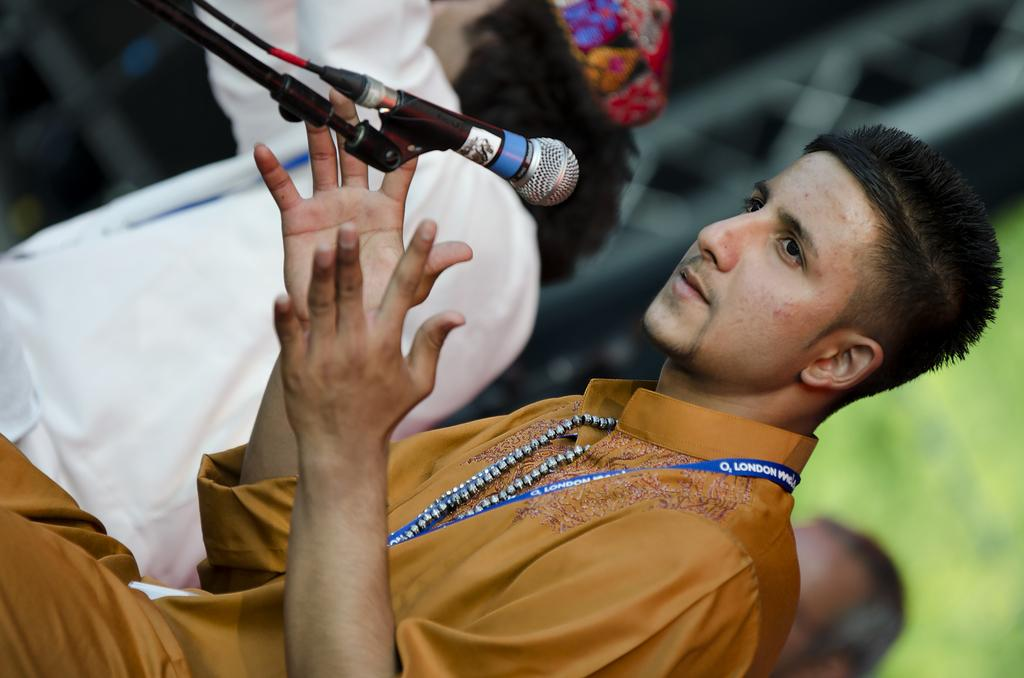What is the boy in the image doing? The boy is sitting in the image. What object is present in the image that is typically used for amplifying sound? There is a microphone in the image. How many people are sitting in the image? There are people sitting in the image, but the exact number is not specified. What type of coat is the kitten wearing in the image? There is no kitten or coat present in the image. How many spoons are visible in the image? There is no mention of spoons in the provided facts, so we cannot determine if any are visible in the image. 